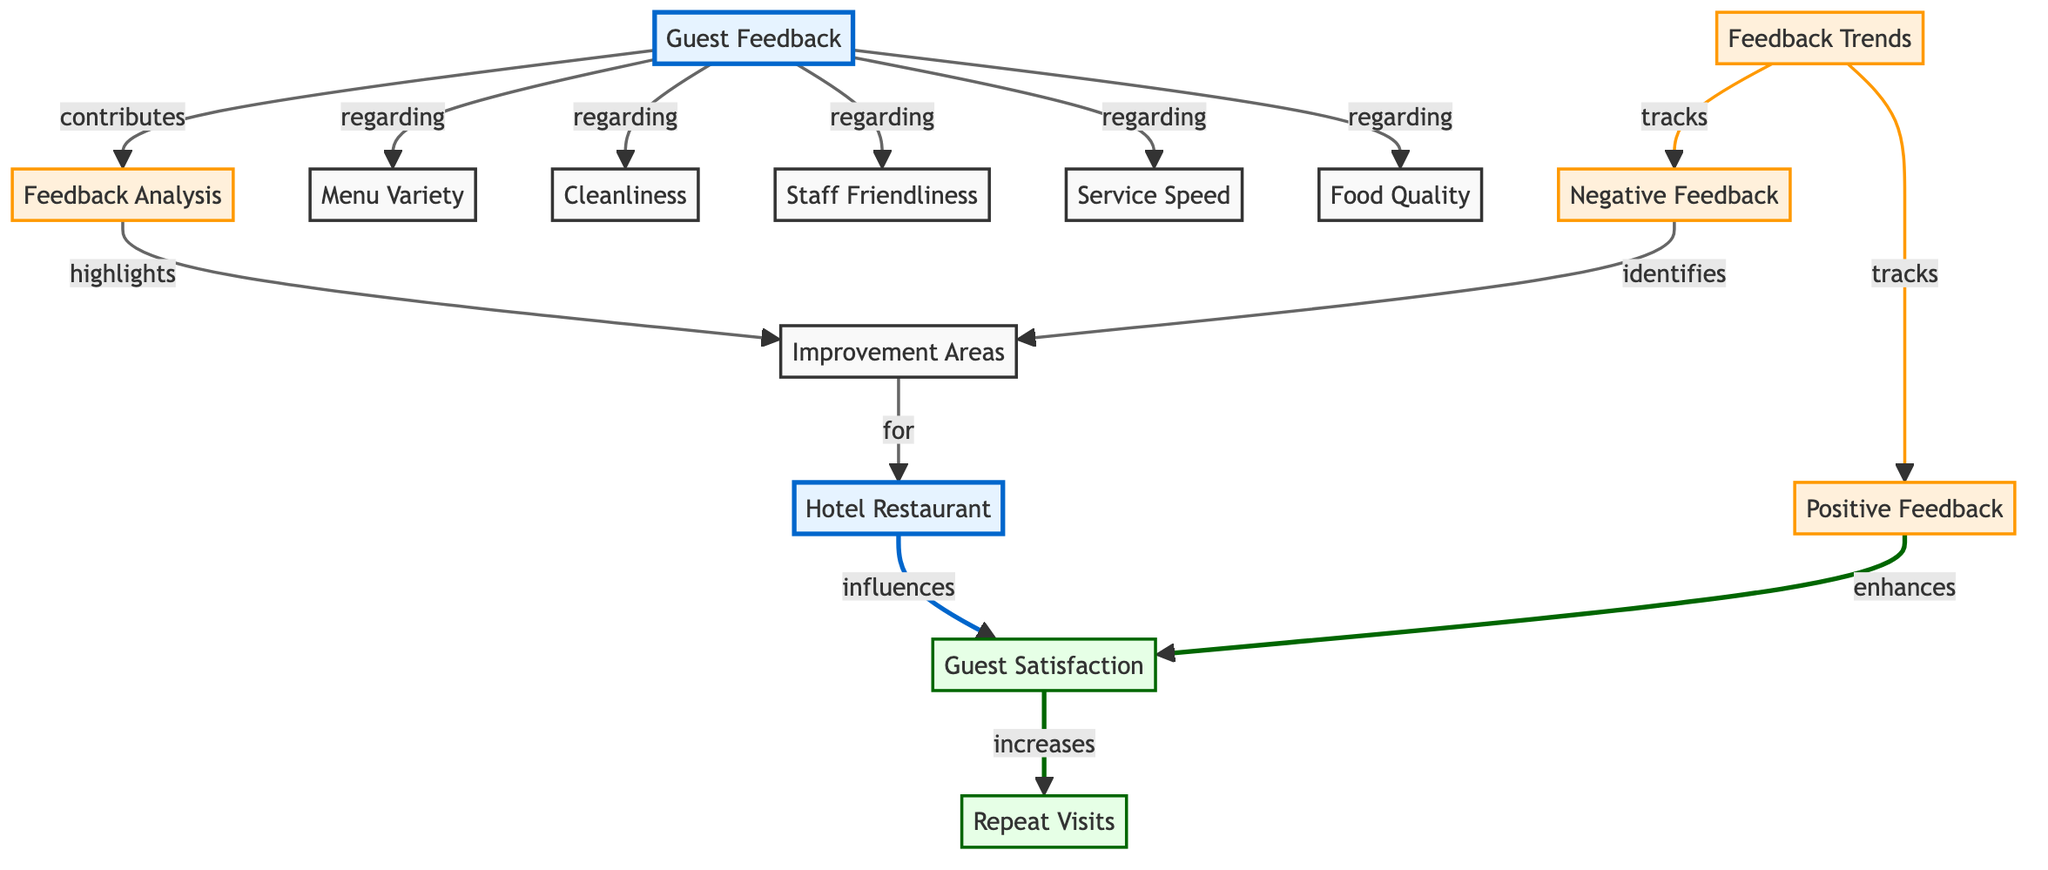What is the main purpose of guest feedback? The main purpose of guest feedback, as indicated in the diagram, is to provide insights regarding various aspects such as food quality, service speed, staff friendliness, cleanliness, and menu variety. This feedback is essential for evaluating the hotel's restaurant operations and improving guest satisfaction.
Answer: Guest Satisfaction Which factors influence guest satisfaction? The diagram shows that the factors influencing guest satisfaction include food quality, service speed, staff friendliness, cleanliness, and menu variety. These factors are directly connected to the hotel restaurant, indicating their importance in determining overall guest satisfaction.
Answer: Food Quality, Service Speed, Staff Friendliness, Cleanliness, Menu Variety How does positive feedback affect guest satisfaction? According to the diagram, positive feedback enhances guest satisfaction. This relationship is depicted through a directional arrow from positive feedback to guest satisfaction, illustrating that an increase in positive feedback leads to higher guest satisfaction levels.
Answer: Enhances What is indicated by the connection between guest satisfaction and repeat visits? The diagram indicates that an increase in guest satisfaction leads to an increase in repeat visits. This suggests a positive correlation where satisfied guests are more likely to return, emphasizing the importance of maintaining high satisfaction levels to encourage repeat business.
Answer: Increases How many aspects of guest feedback are identified in this diagram? The diagram identifies five aspects of guest feedback: food quality, service speed, staff friendliness, cleanliness, and menu variety. Each of these aspects is represented as a separate node connected to the main guest feedback node, highlighting multiple areas for evaluation.
Answer: Five Which area does negative feedback help identify? Negative feedback, as shown in the diagram, helps identify improvement areas. This connection demonstrates that negative feedback serves a constructive purpose by pointing out specific areas that need attention and enhancement in hotel restaurant operations.
Answer: Improvement Areas What analysis does guest feedback contribute to? Guest feedback contributes to feedback analysis. This is illustrated in the diagram where the guest feedback node has a direct connection to the feedback analysis node, showing that the insights drawn from feedback are crucial for assessing performance and making improvements.
Answer: Feedback Analysis What tracks both positive and negative feedback? Feedback trends track both positive and negative feedback, as indicated in the diagram. This dual tracking allows for a comprehensive understanding of guest sentiments and experiences, thereby supporting effective management and improvement strategies.
Answer: Feedback Trends What identifies improvement areas in the hotel restaurant? Negative feedback, according to the diagram, identifies improvement areas. This shows how critiques provided by guests can lead to targeted actions that enhance the overall dining experience within the hotel restaurant.
Answer: Negative Feedback 